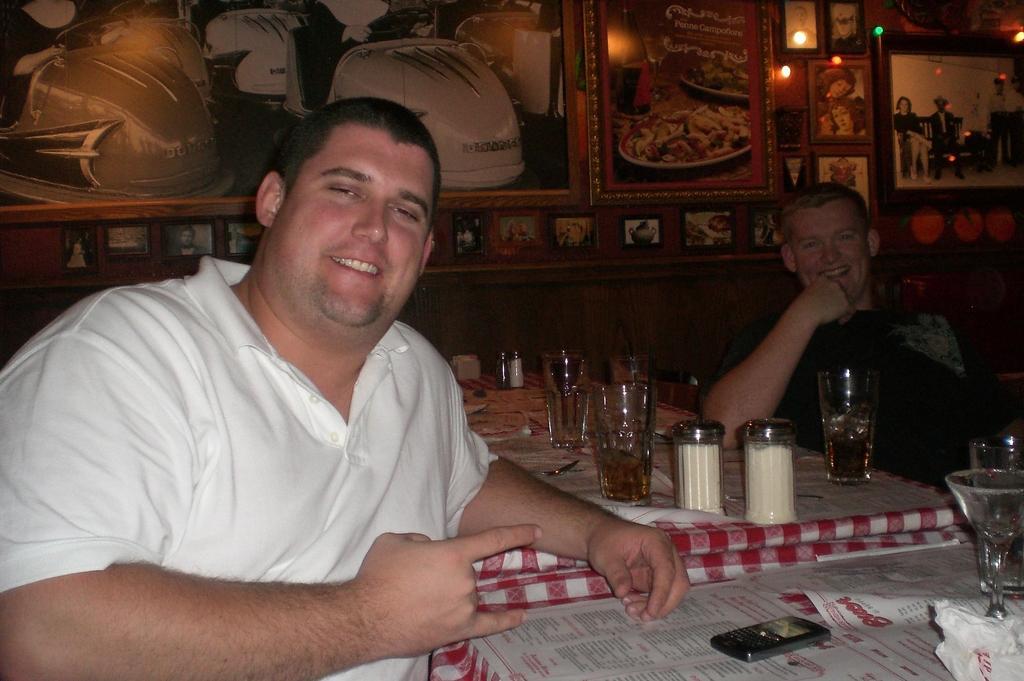Please provide a concise description of this image. This is the picture of two people sitting on the chair in front of the table on which there are some jars, glasses, a phone and a menu card and beside them there is a wall on which there are some frames and some lights. 